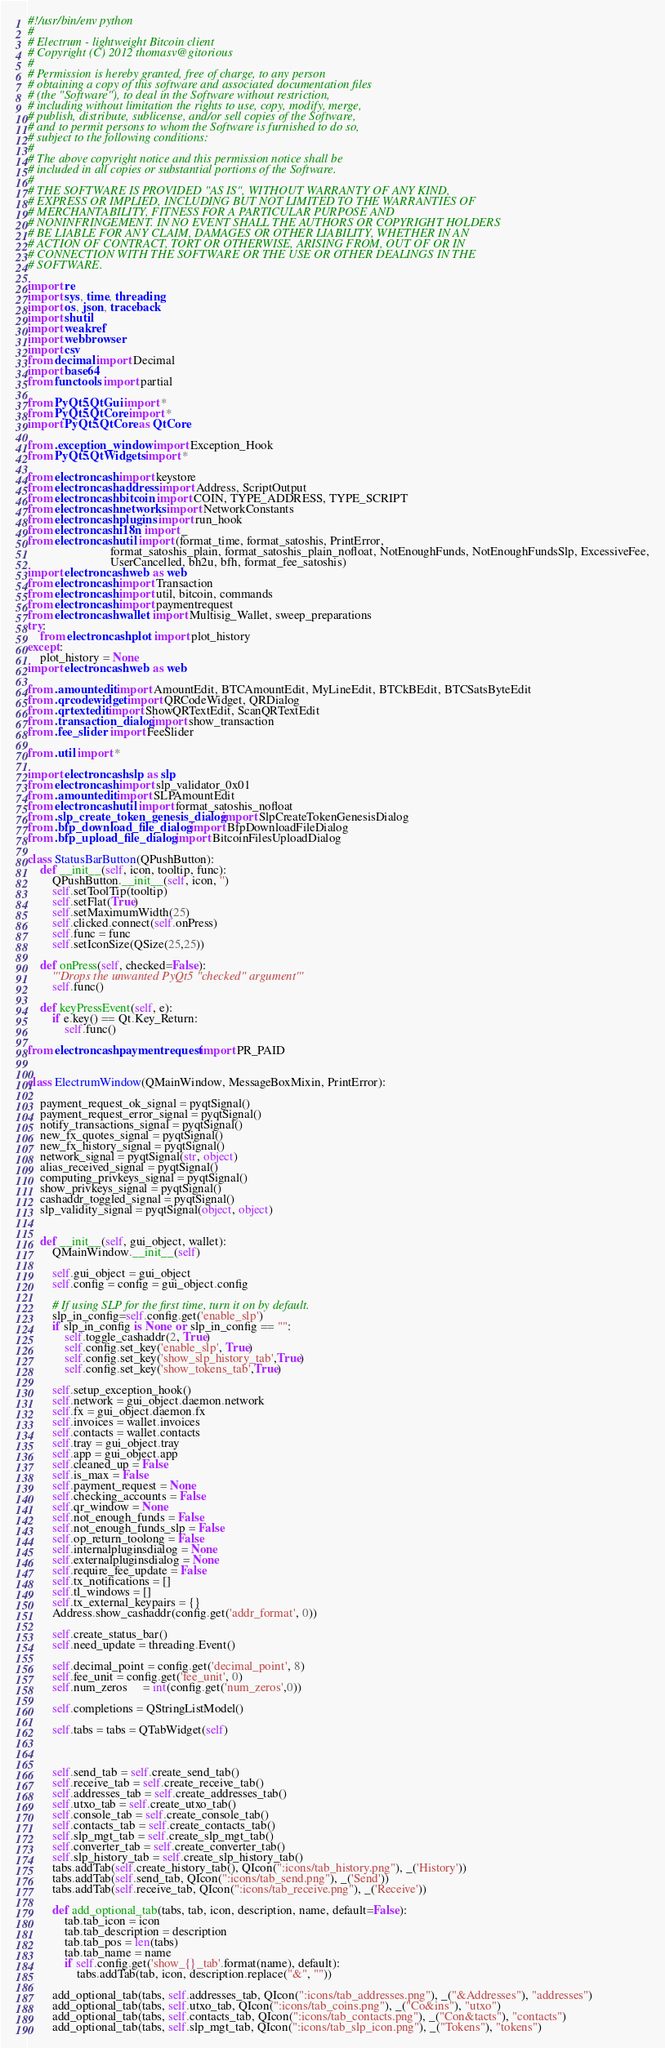<code> <loc_0><loc_0><loc_500><loc_500><_Python_>#!/usr/bin/env python
#
# Electrum - lightweight Bitcoin client
# Copyright (C) 2012 thomasv@gitorious
#
# Permission is hereby granted, free of charge, to any person
# obtaining a copy of this software and associated documentation files
# (the "Software"), to deal in the Software without restriction,
# including without limitation the rights to use, copy, modify, merge,
# publish, distribute, sublicense, and/or sell copies of the Software,
# and to permit persons to whom the Software is furnished to do so,
# subject to the following conditions:
#
# The above copyright notice and this permission notice shall be
# included in all copies or substantial portions of the Software.
#
# THE SOFTWARE IS PROVIDED "AS IS", WITHOUT WARRANTY OF ANY KIND,
# EXPRESS OR IMPLIED, INCLUDING BUT NOT LIMITED TO THE WARRANTIES OF
# MERCHANTABILITY, FITNESS FOR A PARTICULAR PURPOSE AND
# NONINFRINGEMENT. IN NO EVENT SHALL THE AUTHORS OR COPYRIGHT HOLDERS
# BE LIABLE FOR ANY CLAIM, DAMAGES OR OTHER LIABILITY, WHETHER IN AN
# ACTION OF CONTRACT, TORT OR OTHERWISE, ARISING FROM, OUT OF OR IN
# CONNECTION WITH THE SOFTWARE OR THE USE OR OTHER DEALINGS IN THE
# SOFTWARE.

import re
import sys, time, threading
import os, json, traceback
import shutil
import weakref
import webbrowser
import csv
from decimal import Decimal
import base64
from functools import partial

from PyQt5.QtGui import *
from PyQt5.QtCore import *
import PyQt5.QtCore as QtCore

from .exception_window import Exception_Hook
from PyQt5.QtWidgets import *

from electroncash import keystore
from electroncash.address import Address, ScriptOutput
from electroncash.bitcoin import COIN, TYPE_ADDRESS, TYPE_SCRIPT
from electroncash.networks import NetworkConstants
from electroncash.plugins import run_hook
from electroncash.i18n import _
from electroncash.util import (format_time, format_satoshis, PrintError,
                           format_satoshis_plain, format_satoshis_plain_nofloat, NotEnoughFunds, NotEnoughFundsSlp, ExcessiveFee,
                           UserCancelled, bh2u, bfh, format_fee_satoshis)
import electroncash.web as web
from electroncash import Transaction
from electroncash import util, bitcoin, commands
from electroncash import paymentrequest
from electroncash.wallet import Multisig_Wallet, sweep_preparations
try:
    from electroncash.plot import plot_history
except:
    plot_history = None
import electroncash.web as web

from .amountedit import AmountEdit, BTCAmountEdit, MyLineEdit, BTCkBEdit, BTCSatsByteEdit
from .qrcodewidget import QRCodeWidget, QRDialog
from .qrtextedit import ShowQRTextEdit, ScanQRTextEdit
from .transaction_dialog import show_transaction
from .fee_slider import FeeSlider

from .util import *

import electroncash.slp as slp
from electroncash import slp_validator_0x01
from .amountedit import SLPAmountEdit
from electroncash.util import format_satoshis_nofloat
from .slp_create_token_genesis_dialog import SlpCreateTokenGenesisDialog
from .bfp_download_file_dialog import BfpDownloadFileDialog
from .bfp_upload_file_dialog import BitcoinFilesUploadDialog

class StatusBarButton(QPushButton):
    def __init__(self, icon, tooltip, func):
        QPushButton.__init__(self, icon, '')
        self.setToolTip(tooltip)
        self.setFlat(True)
        self.setMaximumWidth(25)
        self.clicked.connect(self.onPress)
        self.func = func
        self.setIconSize(QSize(25,25))

    def onPress(self, checked=False):
        '''Drops the unwanted PyQt5 "checked" argument'''
        self.func()

    def keyPressEvent(self, e):
        if e.key() == Qt.Key_Return:
            self.func()

from electroncash.paymentrequest import PR_PAID


class ElectrumWindow(QMainWindow, MessageBoxMixin, PrintError):

    payment_request_ok_signal = pyqtSignal()
    payment_request_error_signal = pyqtSignal()
    notify_transactions_signal = pyqtSignal()
    new_fx_quotes_signal = pyqtSignal()
    new_fx_history_signal = pyqtSignal()
    network_signal = pyqtSignal(str, object)
    alias_received_signal = pyqtSignal()
    computing_privkeys_signal = pyqtSignal()
    show_privkeys_signal = pyqtSignal()
    cashaddr_toggled_signal = pyqtSignal()
    slp_validity_signal = pyqtSignal(object, object)


    def __init__(self, gui_object, wallet):
        QMainWindow.__init__(self)

        self.gui_object = gui_object
        self.config = config = gui_object.config

        # If using SLP for the first time, turn it on by default.
        slp_in_config=self.config.get('enable_slp')
        if slp_in_config is None or slp_in_config == "":
            self.toggle_cashaddr(2, True)            
            self.config.set_key('enable_slp', True)
            self.config.set_key('show_slp_history_tab',True)
            self.config.set_key('show_tokens_tab',True) 

        self.setup_exception_hook()
        self.network = gui_object.daemon.network
        self.fx = gui_object.daemon.fx
        self.invoices = wallet.invoices
        self.contacts = wallet.contacts
        self.tray = gui_object.tray
        self.app = gui_object.app
        self.cleaned_up = False
        self.is_max = False
        self.payment_request = None
        self.checking_accounts = False
        self.qr_window = None
        self.not_enough_funds = False
        self.not_enough_funds_slp = False
        self.op_return_toolong = False
        self.internalpluginsdialog = None
        self.externalpluginsdialog = None
        self.require_fee_update = False
        self.tx_notifications = []
        self.tl_windows = []
        self.tx_external_keypairs = {}
        Address.show_cashaddr(config.get('addr_format', 0))

        self.create_status_bar()
        self.need_update = threading.Event()

        self.decimal_point = config.get('decimal_point', 8)
        self.fee_unit = config.get('fee_unit', 0)
        self.num_zeros     = int(config.get('num_zeros',0))

        self.completions = QStringListModel()

        self.tabs = tabs = QTabWidget(self)



        self.send_tab = self.create_send_tab()
        self.receive_tab = self.create_receive_tab()
        self.addresses_tab = self.create_addresses_tab()
        self.utxo_tab = self.create_utxo_tab()
        self.console_tab = self.create_console_tab()
        self.contacts_tab = self.create_contacts_tab()
        self.slp_mgt_tab = self.create_slp_mgt_tab()
        self.converter_tab = self.create_converter_tab()
        self.slp_history_tab = self.create_slp_history_tab()
        tabs.addTab(self.create_history_tab(), QIcon(":icons/tab_history.png"), _('History'))
        tabs.addTab(self.send_tab, QIcon(":icons/tab_send.png"), _('Send'))
        tabs.addTab(self.receive_tab, QIcon(":icons/tab_receive.png"), _('Receive'))

        def add_optional_tab(tabs, tab, icon, description, name, default=False):
            tab.tab_icon = icon
            tab.tab_description = description
            tab.tab_pos = len(tabs)
            tab.tab_name = name
            if self.config.get('show_{}_tab'.format(name), default):
                tabs.addTab(tab, icon, description.replace("&", ""))

        add_optional_tab(tabs, self.addresses_tab, QIcon(":icons/tab_addresses.png"), _("&Addresses"), "addresses")
        add_optional_tab(tabs, self.utxo_tab, QIcon(":icons/tab_coins.png"), _("Co&ins"), "utxo")
        add_optional_tab(tabs, self.contacts_tab, QIcon(":icons/tab_contacts.png"), _("Con&tacts"), "contacts")
        add_optional_tab(tabs, self.slp_mgt_tab, QIcon(":icons/tab_slp_icon.png"), _("Tokens"), "tokens")</code> 